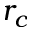Convert formula to latex. <formula><loc_0><loc_0><loc_500><loc_500>r _ { c }</formula> 